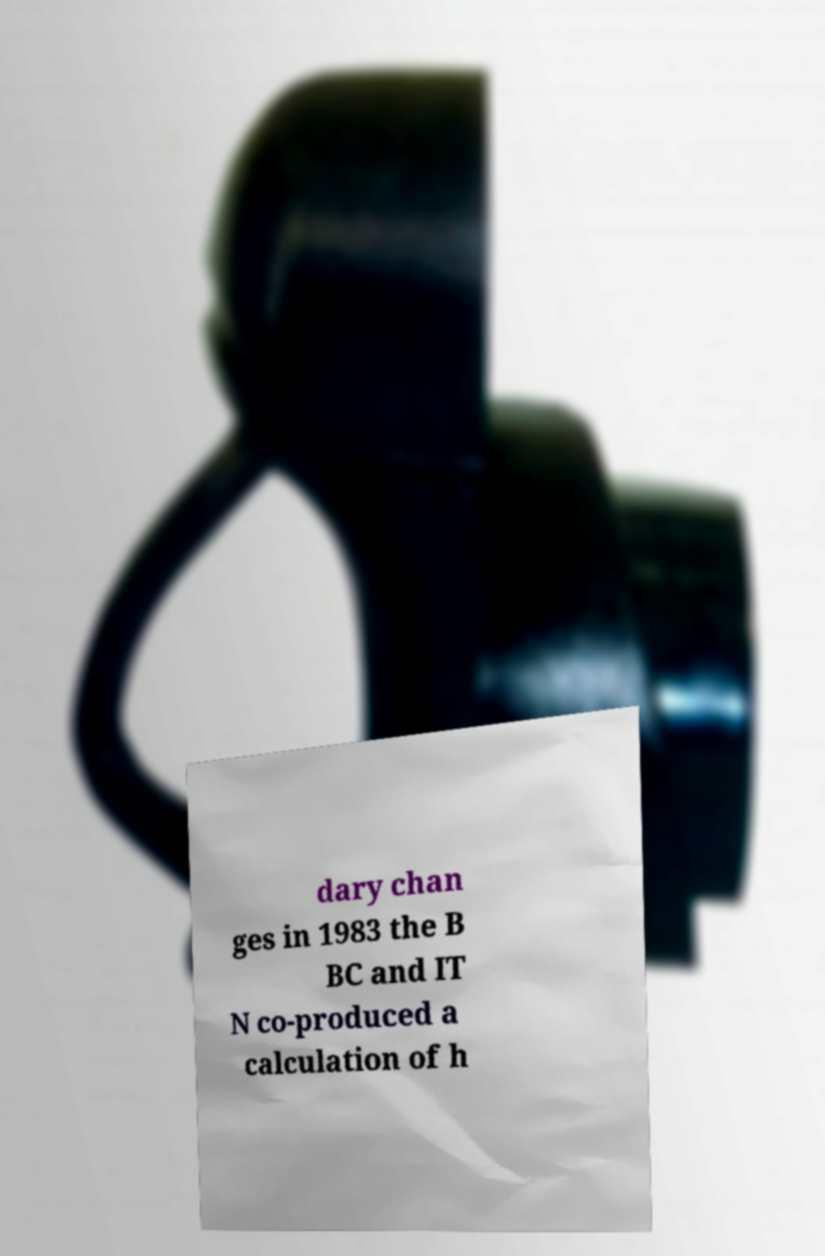What messages or text are displayed in this image? I need them in a readable, typed format. dary chan ges in 1983 the B BC and IT N co-produced a calculation of h 